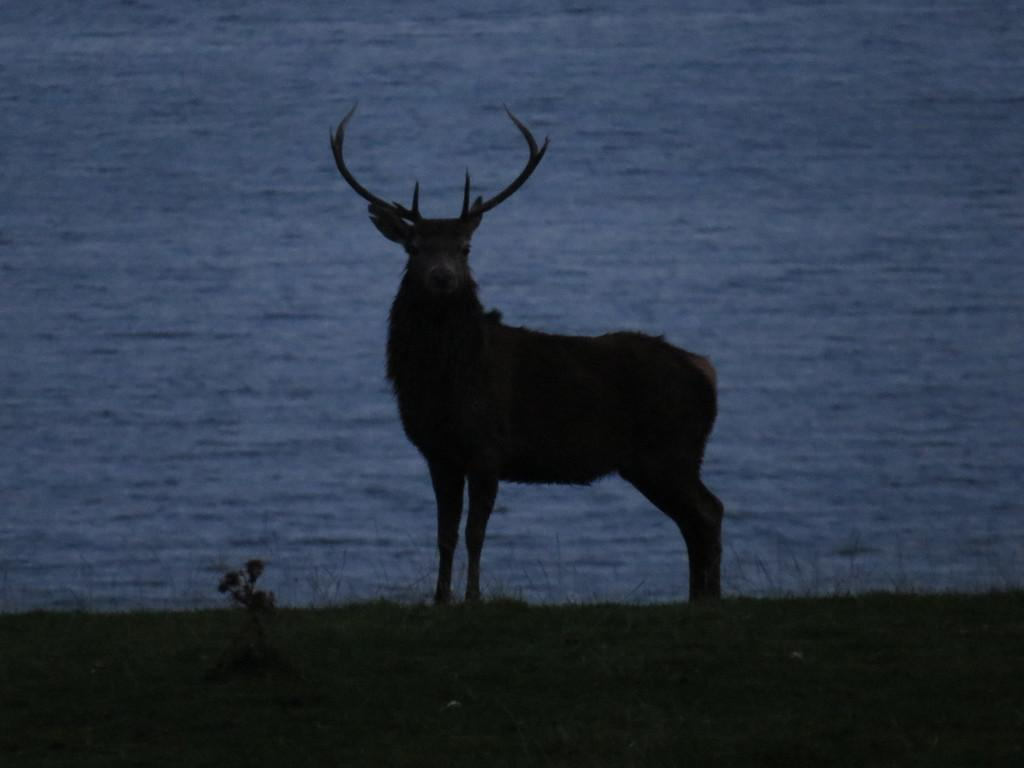What type of animal can be seen on the ground in the image? There is an animal on the ground in the image, but the specific type cannot be determined from the facts provided. What else is on the ground in the image besides the animal? There is a small plant and grass on the ground in the image. What can be seen in the background of the image? There is water visible in the background of the image. Is there an oil spill visible in the image? There is no mention of an oil spill in the provided facts, and therefore it cannot be determined if one is present in the image. Can you describe the exchange between the animal and the plant in the image? There is no exchange between the animal and the plant in the image, as the facts provided do not mention any interaction between them. 